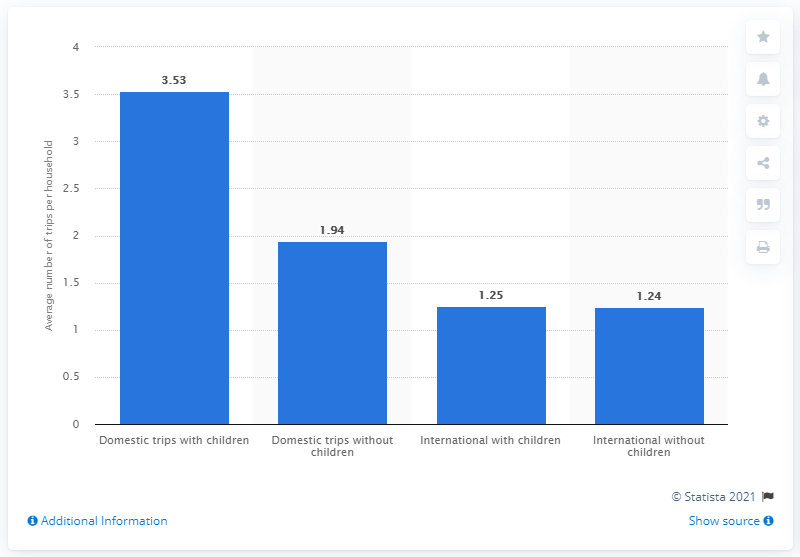List a handful of essential elements in this visual. In the last year, the average number of domestic trips taken by households with children was 3.53. 